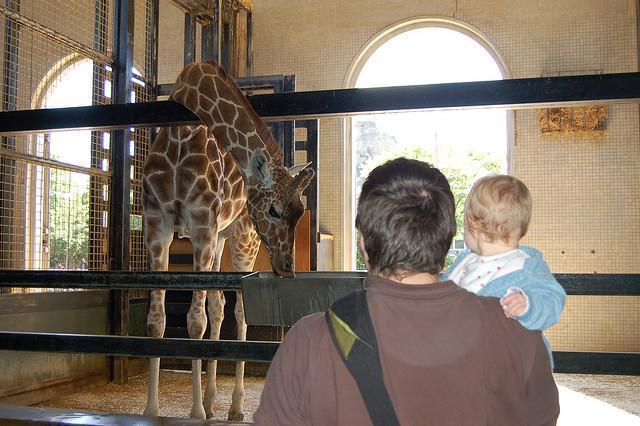How many people are there?
Give a very brief answer. 2. How many cars are there with yellow color?
Give a very brief answer. 0. 